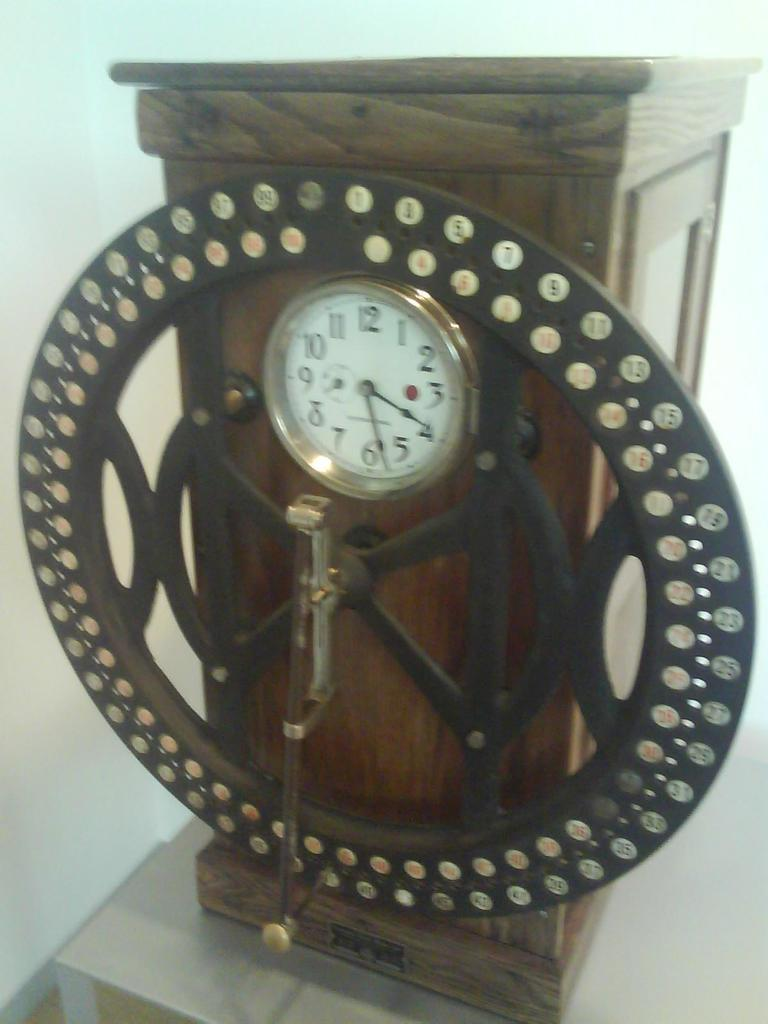Provide a one-sentence caption for the provided image. A clock that reads 4:27 is mounted on a piece of wood. 